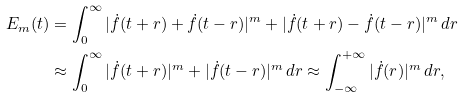Convert formula to latex. <formula><loc_0><loc_0><loc_500><loc_500>E _ { m } ( t ) & = \int _ { 0 } ^ { \infty } | \dot { f } ( t + r ) + \dot { f } ( t - r ) | ^ { m } + | \dot { f } ( t + r ) - \dot { f } ( t - r ) | ^ { m } \, d r \\ & \approx \int _ { 0 } ^ { \infty } | \dot { f } ( t + r ) | ^ { m } + | \dot { f } ( t - r ) | ^ { m } \, d r \approx \int _ { - \infty } ^ { + \infty } | \dot { f } ( r ) | ^ { m } \, d r ,</formula> 